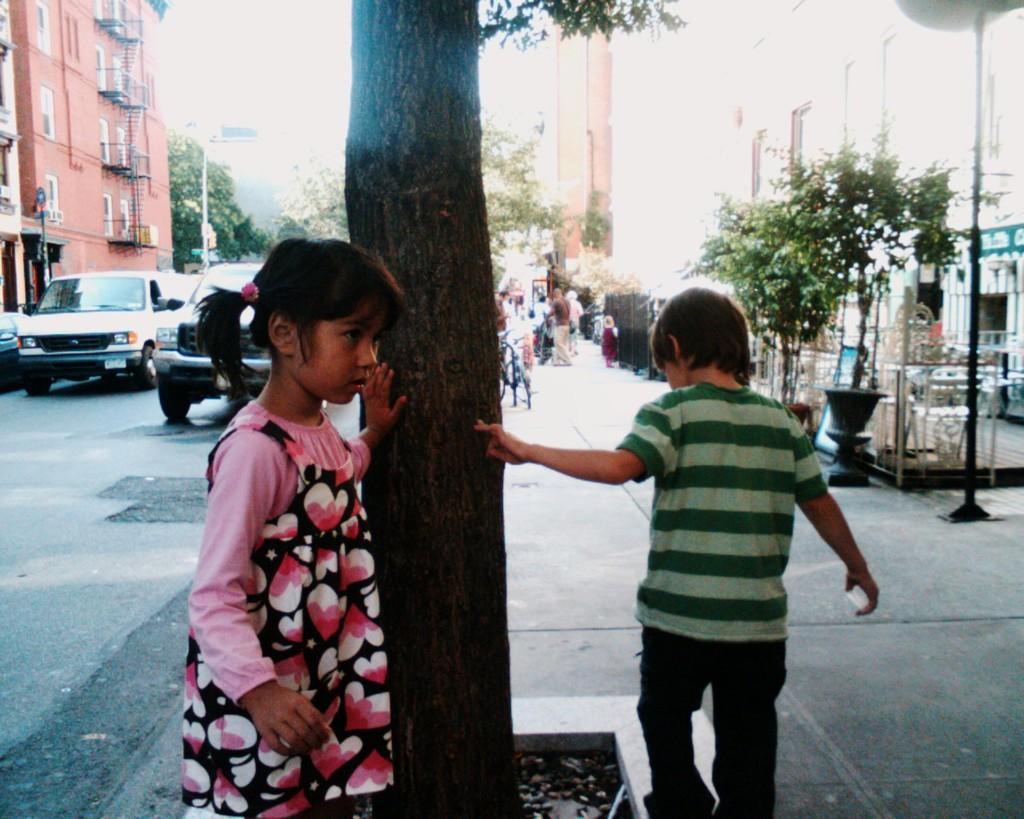In one or two sentences, can you explain what this image depicts? In this image I can see there is a road. And on the road there is are cars and persons. And beside the road there are buildings at right and left side. There are trees, Fence, light pole and a board. And at the top there is a sky. 